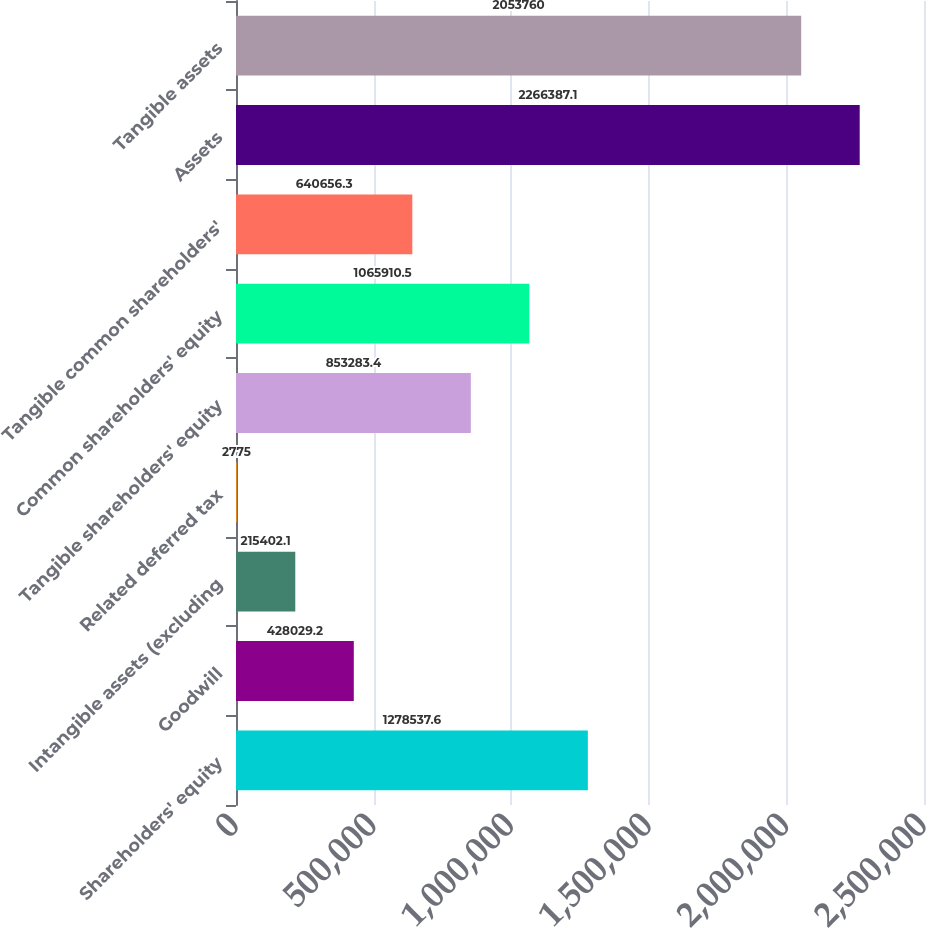Convert chart. <chart><loc_0><loc_0><loc_500><loc_500><bar_chart><fcel>Shareholders' equity<fcel>Goodwill<fcel>Intangible assets (excluding<fcel>Related deferred tax<fcel>Tangible shareholders' equity<fcel>Common shareholders' equity<fcel>Tangible common shareholders'<fcel>Assets<fcel>Tangible assets<nl><fcel>1.27854e+06<fcel>428029<fcel>215402<fcel>2775<fcel>853283<fcel>1.06591e+06<fcel>640656<fcel>2.26639e+06<fcel>2.05376e+06<nl></chart> 